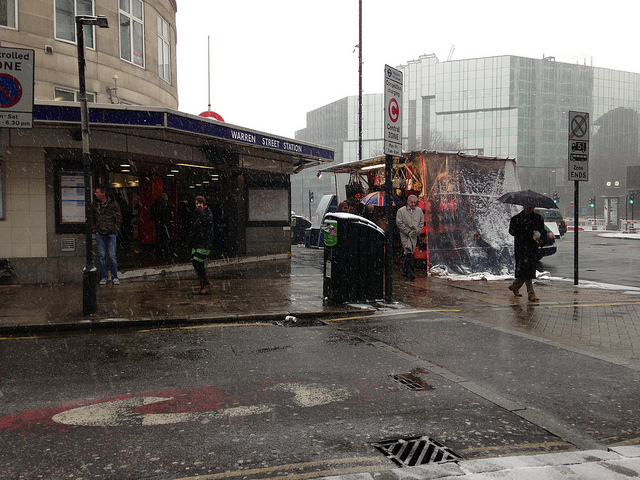<image>What sign is next to the man? It is unknown what sign is next to the man. It can be a road sign, traffic sign, or a no parking sign. What sign is next to the man? I am not sure what sign is next to the man. It can be seen 'no parking', 'traffic sign', 'watch for emergency vehicles', 'road sign', 'no crossing', 'no entry', 'do not cross', 'bus sign' or 'crosswalk'. 